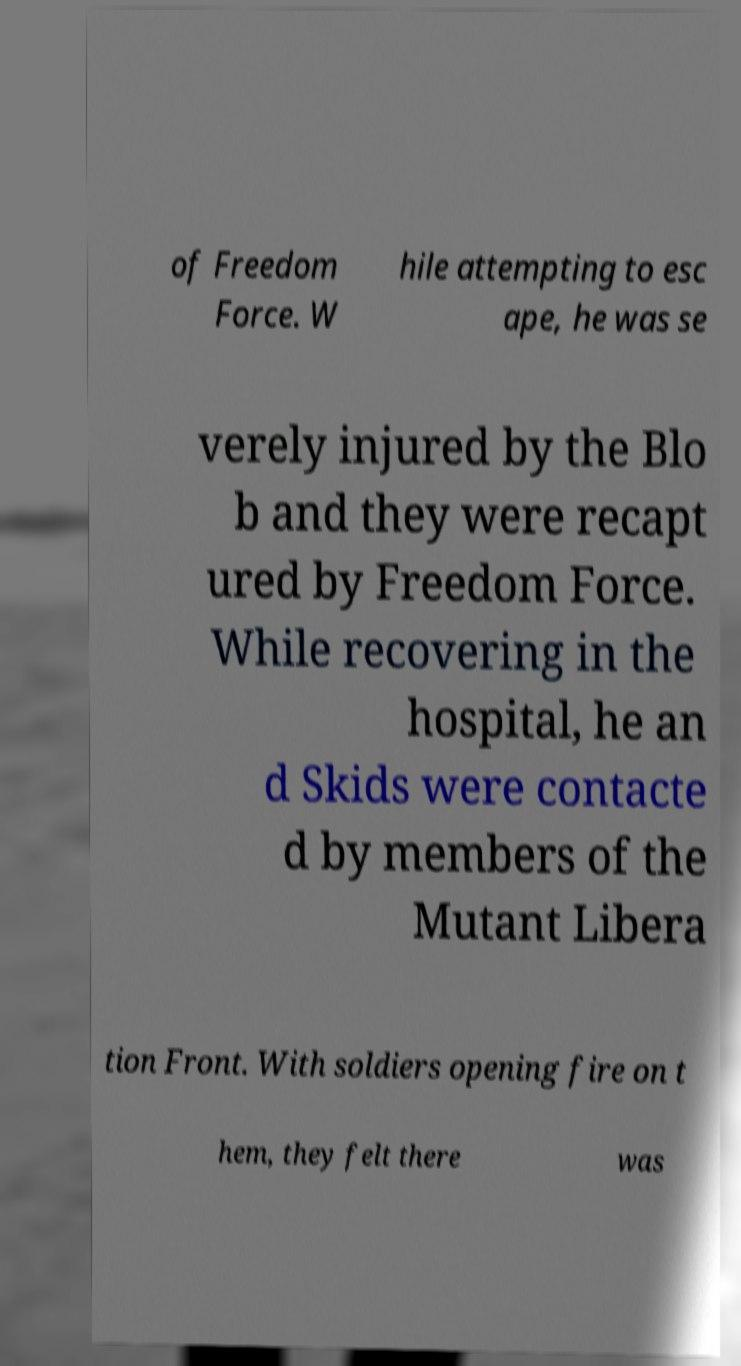For documentation purposes, I need the text within this image transcribed. Could you provide that? of Freedom Force. W hile attempting to esc ape, he was se verely injured by the Blo b and they were recapt ured by Freedom Force. While recovering in the hospital, he an d Skids were contacte d by members of the Mutant Libera tion Front. With soldiers opening fire on t hem, they felt there was 